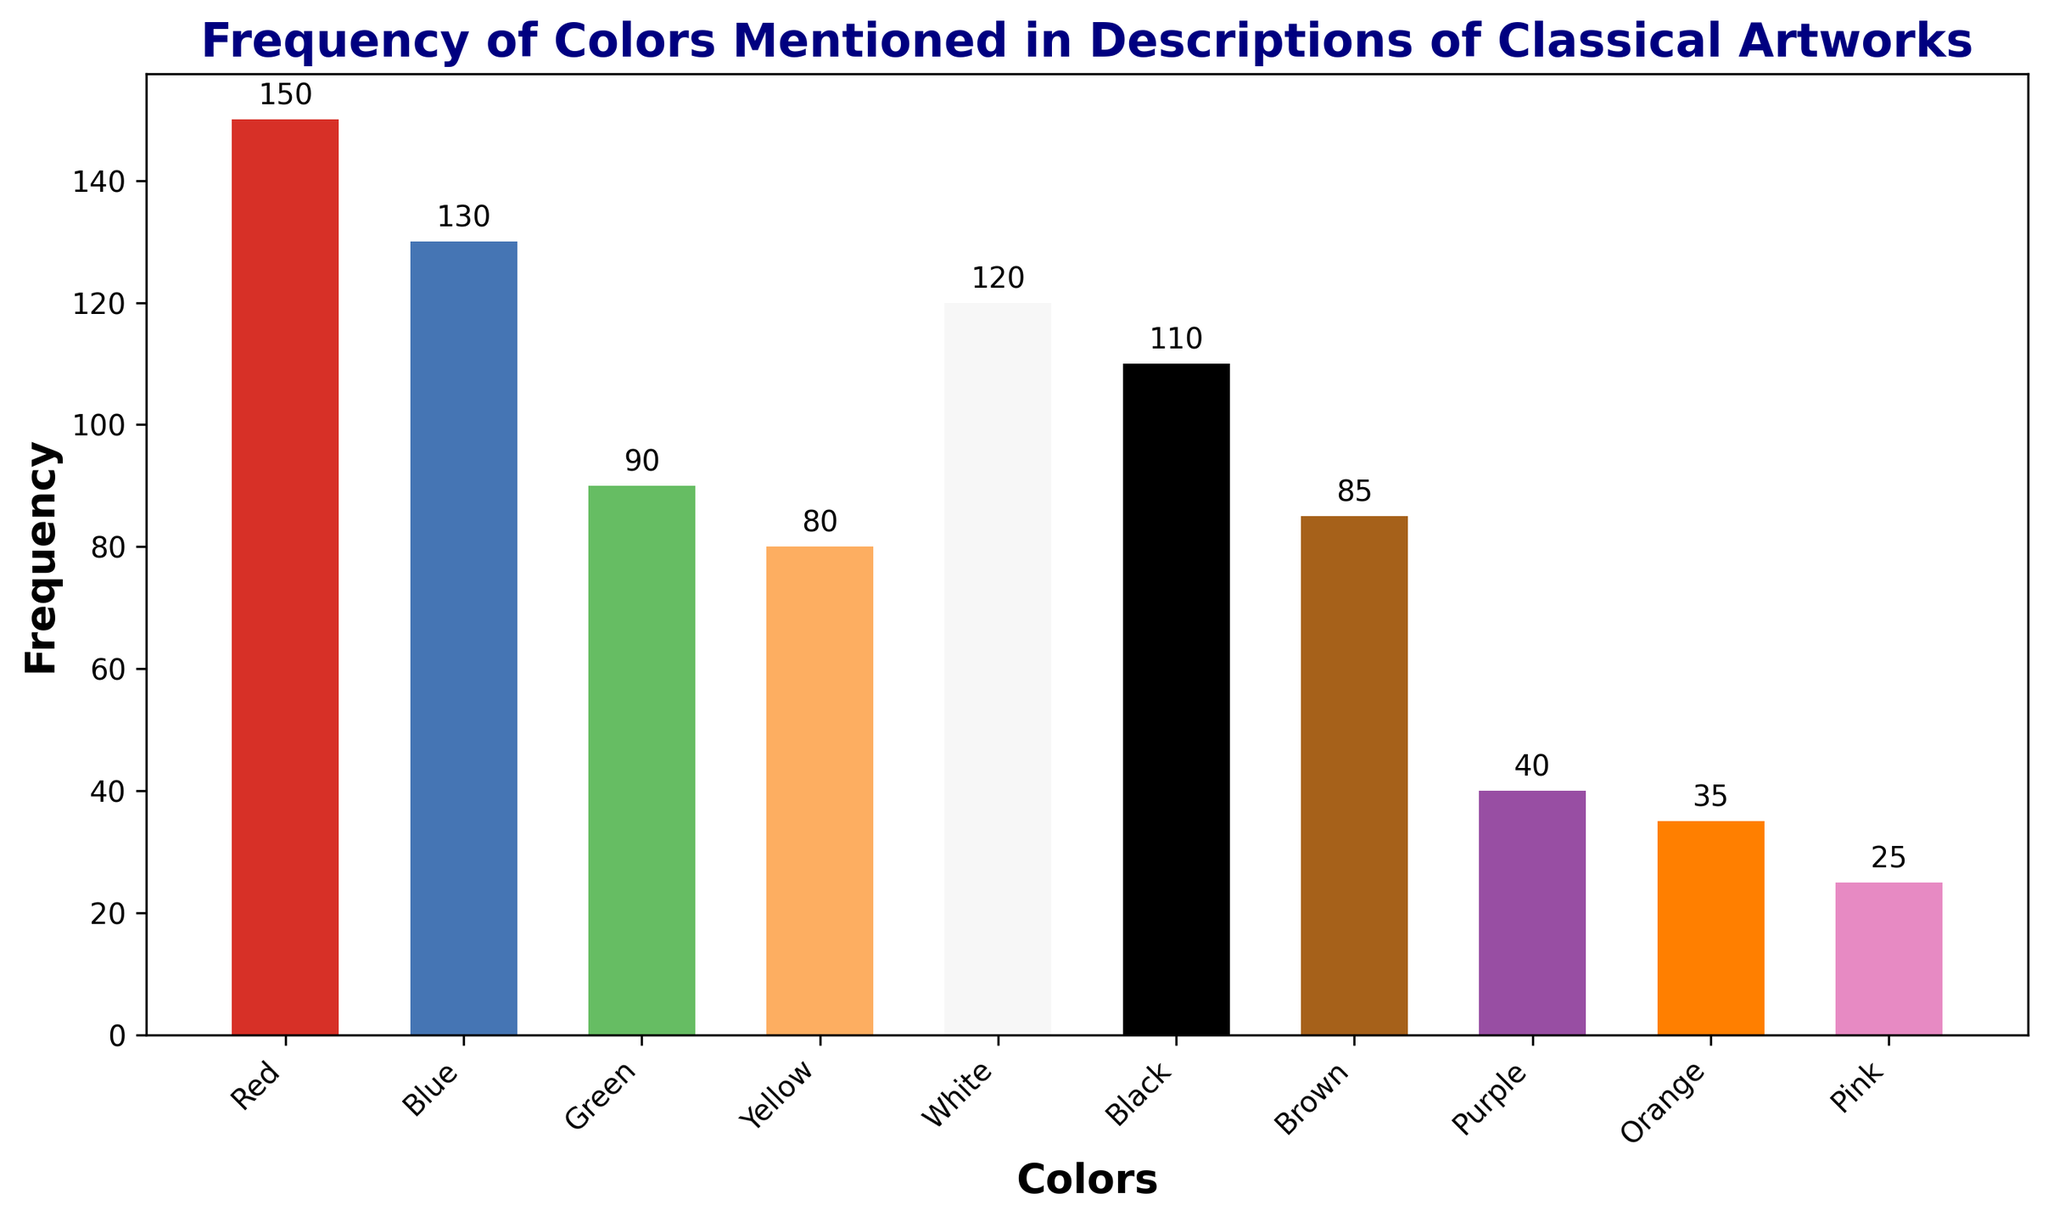What color is mentioned the most frequently in descriptions of classical artworks? Red is mentioned the most frequently, as it has the highest bar in the chart with a frequency of 150.
Answer: Red Which color has the least frequency mentioned in the descriptions? Pink has the least frequency, as indicated by the shortest bar with a frequency of 25.
Answer: Pink How many more times is Red mentioned compared to Purple? Red is mentioned 150 times while Purple is mentioned 40 times. So, Red is mentioned 150 - 40 = 110 more times.
Answer: 110 What is the total frequency of all colors combined? Adding the frequencies of all the colors: 150 + 130 + 90 + 80 + 120 + 110 + 85 + 40 + 35 + 25 = 865.
Answer: 865 Is the frequency of Blue greater than Black? Yes, the frequency of Blue is 130 while Black's frequency is 110, which means Blue is mentioned more often than Black.
Answer: Yes Which color is mentioned 5th most frequently, and what is its frequency? White is mentioned 5th most frequently with a count of 120.
Answer: White, 120 What is the combined frequency of the three least mentioned colors? The three least mentioned colors are Pink (25), Orange (35), and Purple (40). Their combined frequency is 25 + 35 + 40 = 100.
Answer: 100 Calculate the average frequency of the colors that have a frequency greater than 100. The colors with a frequency greater than 100 are Red (150), Blue (130), White (120), and Black (110). Average frequency = (150 + 130 + 120 + 110) / 4 = 510 / 4 = 127.5.
Answer: 127.5 Are there more colors mentioned less than 50 times or more than 100 times? Colors mentioned less than 50 times: Purple, Orange, Pink (3 colors). Colors mentioned more than 100 times: Red, Blue, White, Black (4 colors). Therefore, there are more colors mentioned more than 100 times.
Answer: More colors mentioned more than 100 times 